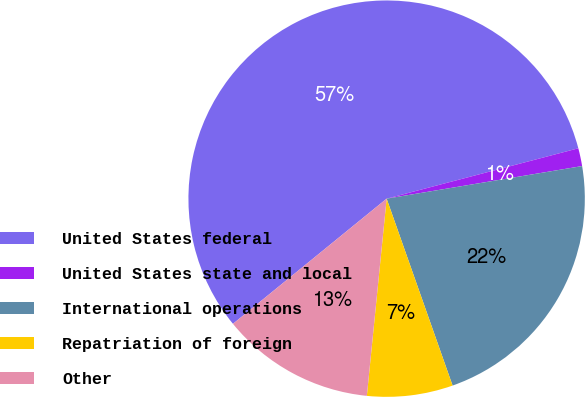Convert chart to OTSL. <chart><loc_0><loc_0><loc_500><loc_500><pie_chart><fcel>United States federal<fcel>United States state and local<fcel>International operations<fcel>Repatriation of foreign<fcel>Other<nl><fcel>56.79%<fcel>1.46%<fcel>22.23%<fcel>6.99%<fcel>12.53%<nl></chart> 